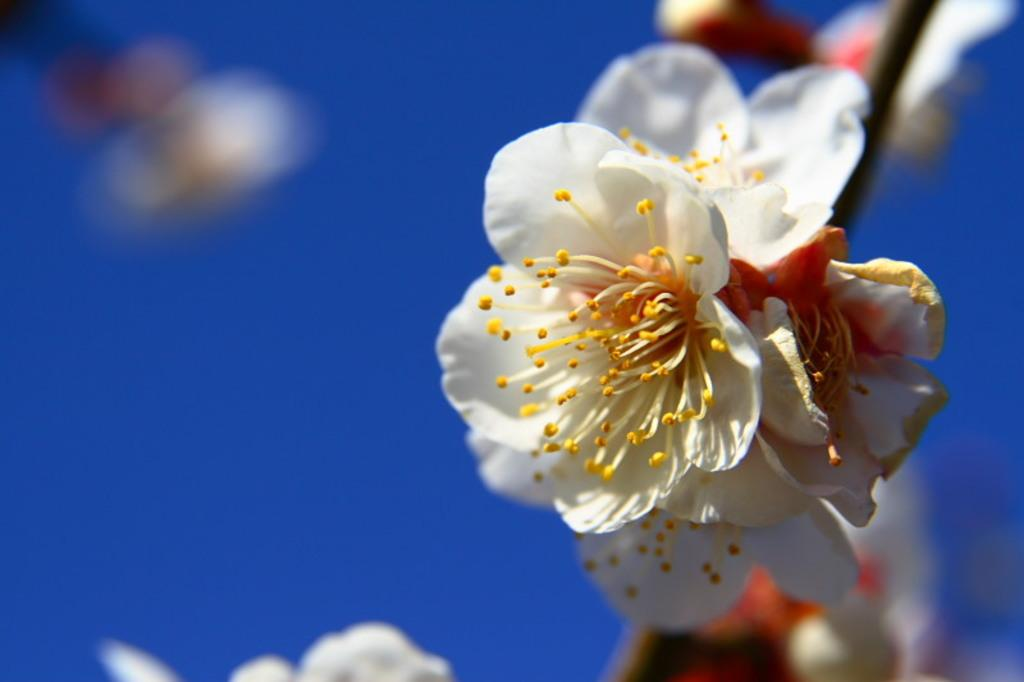What type of vegetation is on the right side of the image? There are flowers on the right side of the image. Can you describe the background of the image? The background area of the image is blurred. How many beds are visible in the image? There are no beds present in the image. What type of knowledge is being shared in the image? There is no knowledge being shared in the image, as it only features flowers and a blurred background. 